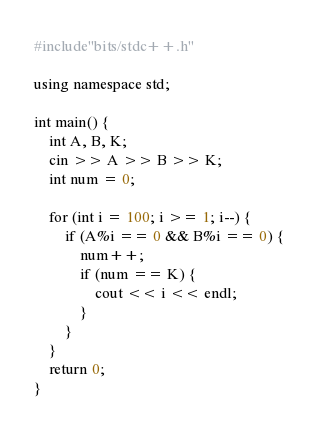Convert code to text. <code><loc_0><loc_0><loc_500><loc_500><_C++_>#include"bits/stdc++.h"

using namespace std;

int main() {
	int A, B, K;
	cin >> A >> B >> K;
	int num = 0;

	for (int i = 100; i >= 1; i--) {
		if (A%i == 0 && B%i == 0) {
			num++;
			if (num == K) {
				cout << i << endl;
			}
		}
	}
	return 0;
}</code> 